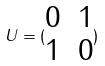Convert formula to latex. <formula><loc_0><loc_0><loc_500><loc_500>U = ( \begin{matrix} 0 & 1 \\ 1 & 0 \end{matrix} )</formula> 